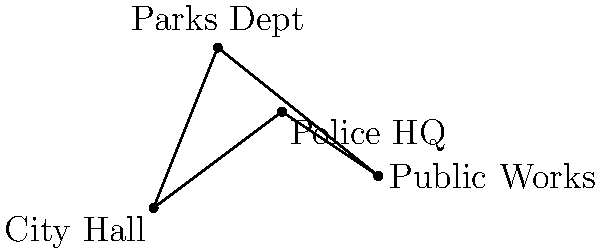As a local government official, you're tasked with optimizing the route for document delivery between four key buildings: City Hall (0,0), Police HQ (4,3), Public Works (7,1), and Parks Department (2,5). To minimize travel time and reduce bureaucratic delays, you need to calculate the shortest possible path that visits all four buildings exactly once and returns to the starting point. Using the distance formula, $d = \sqrt{(x_2-x_1)^2 + (y_2-y_1)^2}$, determine the total distance of the shortest possible route (rounded to two decimal places). To solve this problem, we need to calculate the distances between all pairs of buildings and find the shortest possible route that visits all buildings once and returns to the starting point. This is known as the Traveling Salesman Problem.

Step 1: Calculate distances between all pairs of buildings using the distance formula:
$d = \sqrt{(x_2-x_1)^2 + (y_2-y_1)^2}$

City Hall (A) to Police HQ (B): $d_{AB} = \sqrt{(4-0)^2 + (3-0)^2} = 5$
City Hall (A) to Public Works (C): $d_{AC} = \sqrt{(7-0)^2 + (1-0)^2} = \sqrt{50} \approx 7.07$
City Hall (A) to Parks Dept (D): $d_{AD} = \sqrt{(2-0)^2 + (5-0)^2} = \sqrt{29} \approx 5.39$
Police HQ (B) to Public Works (C): $d_{BC} = \sqrt{(7-4)^2 + (1-3)^2} = \sqrt{13} \approx 3.61$
Police HQ (B) to Parks Dept (D): $d_{BD} = \sqrt{(2-4)^2 + (5-3)^2} = \sqrt{8} \approx 2.83$
Public Works (C) to Parks Dept (D): $d_{CD} = \sqrt{(2-7)^2 + (5-1)^2} = \sqrt{41} \approx 6.40$

Step 2: Determine all possible routes and their total distances:

1. A-B-C-D-A: $5 + 3.61 + 6.40 + 5.39 = 20.40$
2. A-B-D-C-A: $5 + 2.83 + 6.40 + 7.07 = 21.30$
3. A-C-B-D-A: $7.07 + 3.61 + 2.83 + 5.39 = 18.90$
4. A-C-D-B-A: $7.07 + 6.40 + 2.83 + 5 = 21.30$
5. A-D-B-C-A: $5.39 + 2.83 + 3.61 + 7.07 = 18.90$
6. A-D-C-B-A: $5.39 + 6.40 + 3.61 + 5 = 20.40$

Step 3: Identify the shortest route:
The shortest routes are A-C-B-D-A and A-D-B-C-A, both with a total distance of 18.90 units.
Answer: 18.90 units 